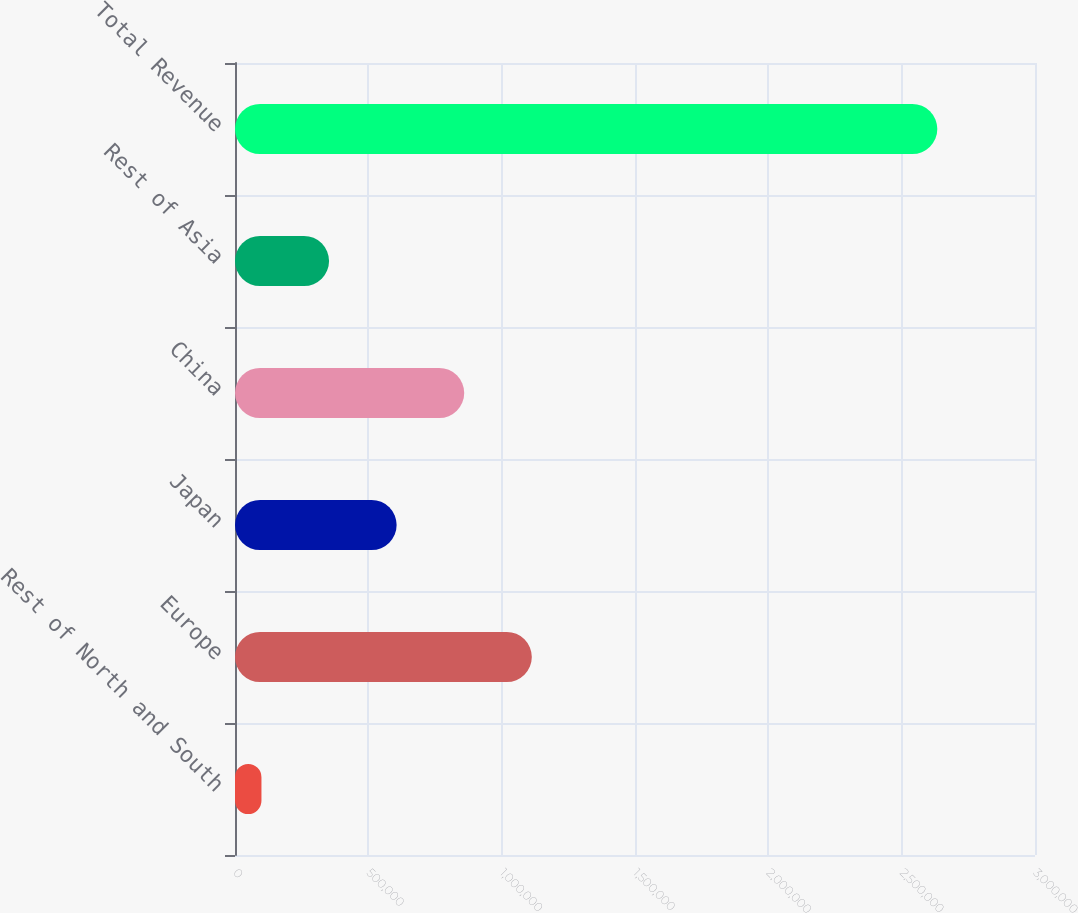<chart> <loc_0><loc_0><loc_500><loc_500><bar_chart><fcel>Rest of North and South<fcel>Europe<fcel>Japan<fcel>China<fcel>Rest of Asia<fcel>Total Revenue<nl><fcel>99215<fcel>1.113e+06<fcel>606110<fcel>859557<fcel>352662<fcel>2.63369e+06<nl></chart> 